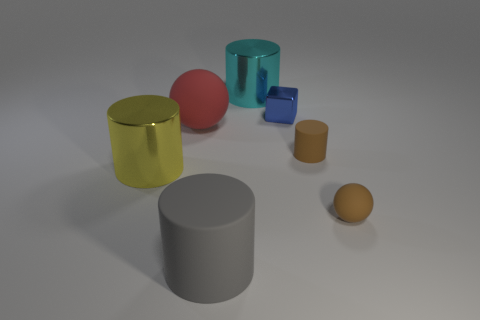There is a object that is both in front of the yellow thing and on the left side of the tiny rubber sphere; what is its color?
Keep it short and to the point. Gray. What size is the brown thing that is the same shape as the large red thing?
Provide a short and direct response. Small. What number of brown spheres are the same size as the gray object?
Keep it short and to the point. 0. What is the material of the big ball?
Your response must be concise. Rubber. Are there any brown balls behind the large gray rubber thing?
Your answer should be very brief. Yes. What size is the brown cylinder that is made of the same material as the small sphere?
Provide a succinct answer. Small. How many small matte spheres have the same color as the small cylinder?
Provide a succinct answer. 1. Is the number of big red spheres to the right of the red rubber sphere less than the number of big gray rubber things behind the tiny brown matte sphere?
Provide a short and direct response. No. What size is the brown thing that is behind the large yellow thing?
Give a very brief answer. Small. What size is the object that is the same color as the small cylinder?
Offer a very short reply. Small. 